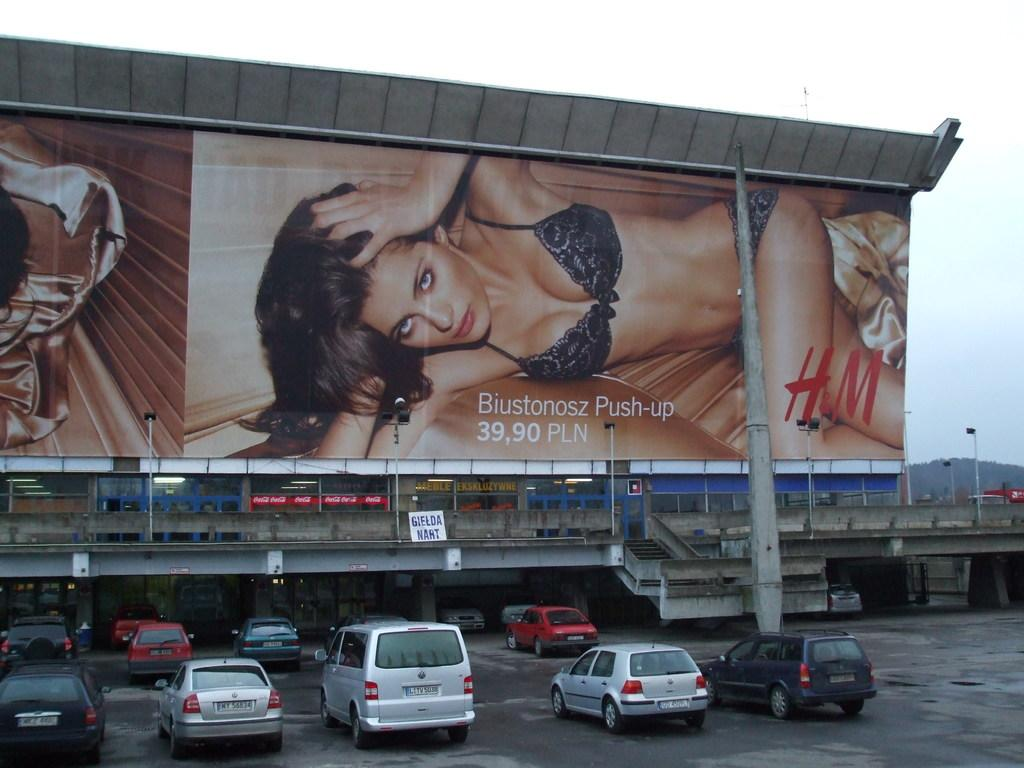<image>
Create a compact narrative representing the image presented. An H&M ad for a Biustonosz Push-up for 39,90 PLN displayed over a parking lot 